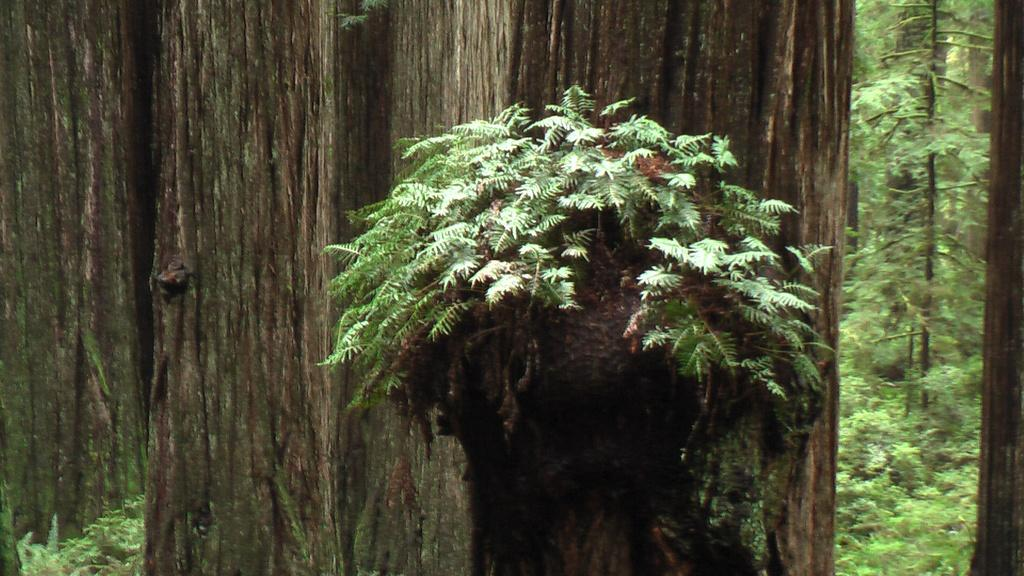What is the main subject in the middle of the image? There is a tree trunk with plants in the middle of the image. What can be seen in the background of the image? There are tree trunks in the background of the image. Where are the trees located in the image? There are trees in the right corner of the image. What is the chance of finding a hall in the image? There is no mention of a hall in the image, so it cannot be determined if there is a chance of finding one. 